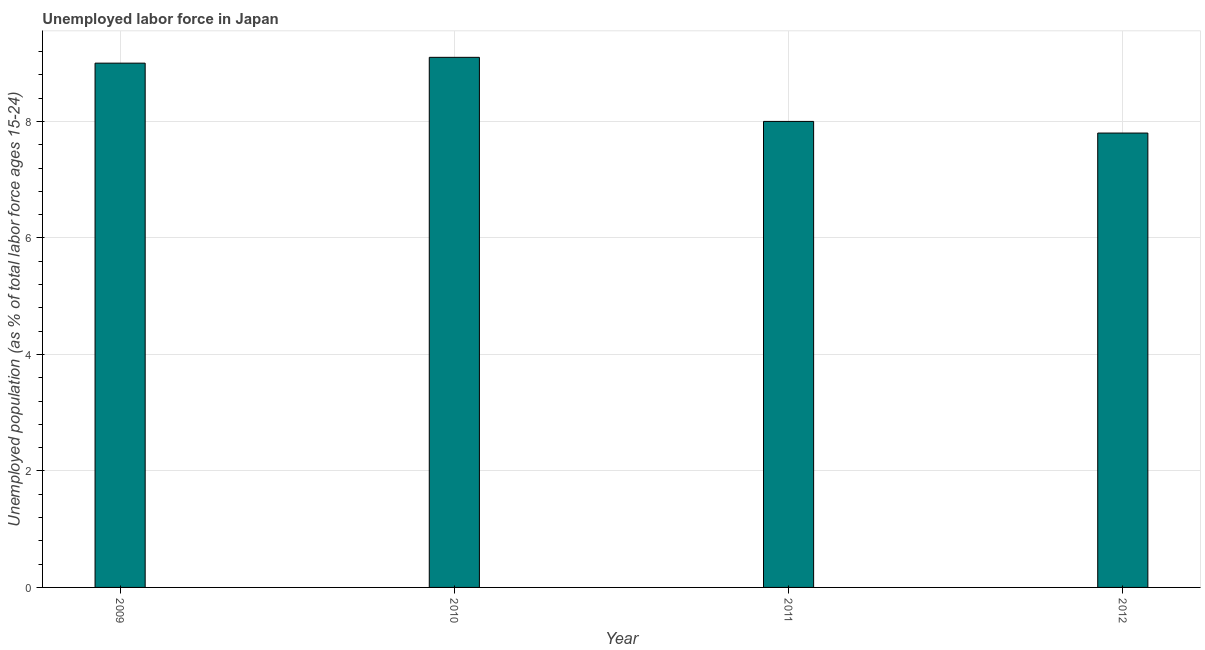What is the title of the graph?
Your answer should be compact. Unemployed labor force in Japan. What is the label or title of the X-axis?
Keep it short and to the point. Year. What is the label or title of the Y-axis?
Provide a short and direct response. Unemployed population (as % of total labor force ages 15-24). Across all years, what is the maximum total unemployed youth population?
Give a very brief answer. 9.1. Across all years, what is the minimum total unemployed youth population?
Offer a very short reply. 7.8. In which year was the total unemployed youth population maximum?
Your response must be concise. 2010. In which year was the total unemployed youth population minimum?
Make the answer very short. 2012. What is the sum of the total unemployed youth population?
Your response must be concise. 33.9. What is the difference between the total unemployed youth population in 2009 and 2010?
Your response must be concise. -0.1. What is the average total unemployed youth population per year?
Your answer should be compact. 8.47. What is the median total unemployed youth population?
Make the answer very short. 8.5. What is the ratio of the total unemployed youth population in 2010 to that in 2011?
Keep it short and to the point. 1.14. Is the total unemployed youth population in 2009 less than that in 2010?
Offer a very short reply. Yes. Is the difference between the total unemployed youth population in 2009 and 2011 greater than the difference between any two years?
Keep it short and to the point. No. What is the difference between the highest and the second highest total unemployed youth population?
Your answer should be compact. 0.1. Is the sum of the total unemployed youth population in 2009 and 2011 greater than the maximum total unemployed youth population across all years?
Ensure brevity in your answer.  Yes. What is the difference between the highest and the lowest total unemployed youth population?
Keep it short and to the point. 1.3. How many bars are there?
Offer a very short reply. 4. Are all the bars in the graph horizontal?
Offer a very short reply. No. How many years are there in the graph?
Your answer should be very brief. 4. What is the Unemployed population (as % of total labor force ages 15-24) of 2009?
Your response must be concise. 9. What is the Unemployed population (as % of total labor force ages 15-24) of 2010?
Ensure brevity in your answer.  9.1. What is the Unemployed population (as % of total labor force ages 15-24) of 2012?
Ensure brevity in your answer.  7.8. What is the difference between the Unemployed population (as % of total labor force ages 15-24) in 2009 and 2011?
Offer a terse response. 1. What is the difference between the Unemployed population (as % of total labor force ages 15-24) in 2010 and 2011?
Your answer should be very brief. 1.1. What is the difference between the Unemployed population (as % of total labor force ages 15-24) in 2010 and 2012?
Give a very brief answer. 1.3. What is the ratio of the Unemployed population (as % of total labor force ages 15-24) in 2009 to that in 2010?
Your answer should be compact. 0.99. What is the ratio of the Unemployed population (as % of total labor force ages 15-24) in 2009 to that in 2011?
Your response must be concise. 1.12. What is the ratio of the Unemployed population (as % of total labor force ages 15-24) in 2009 to that in 2012?
Make the answer very short. 1.15. What is the ratio of the Unemployed population (as % of total labor force ages 15-24) in 2010 to that in 2011?
Make the answer very short. 1.14. What is the ratio of the Unemployed population (as % of total labor force ages 15-24) in 2010 to that in 2012?
Your response must be concise. 1.17. What is the ratio of the Unemployed population (as % of total labor force ages 15-24) in 2011 to that in 2012?
Provide a succinct answer. 1.03. 